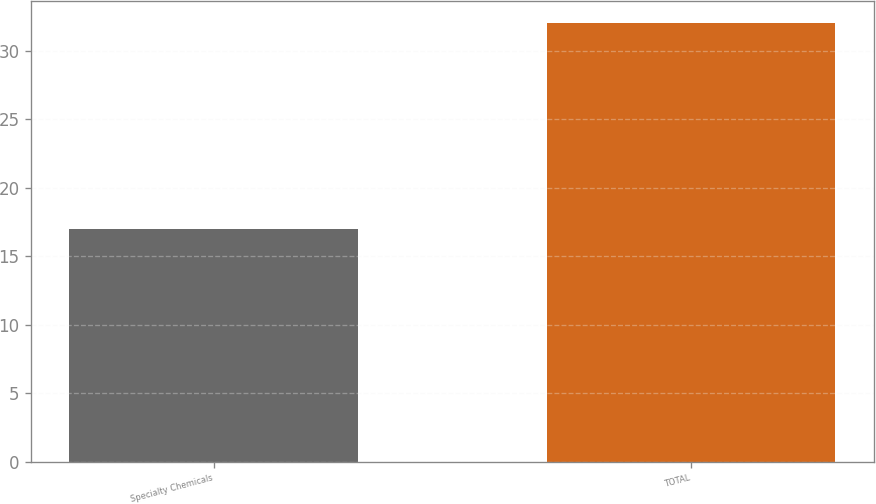Convert chart. <chart><loc_0><loc_0><loc_500><loc_500><bar_chart><fcel>Specialty Chemicals<fcel>TOTAL<nl><fcel>17<fcel>32<nl></chart> 